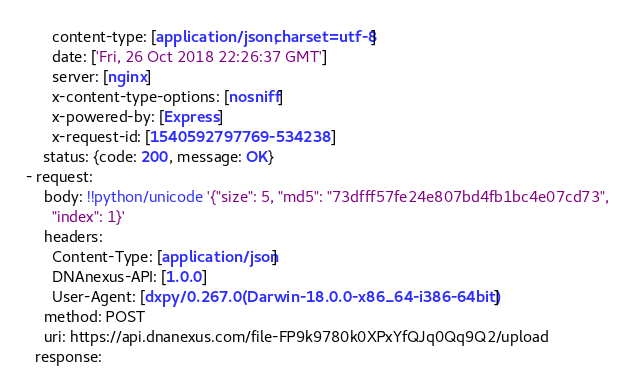<code> <loc_0><loc_0><loc_500><loc_500><_YAML_>      content-type: [application/json; charset=utf-8]
      date: ['Fri, 26 Oct 2018 22:26:37 GMT']
      server: [nginx]
      x-content-type-options: [nosniff]
      x-powered-by: [Express]
      x-request-id: [1540592797769-534238]
    status: {code: 200, message: OK}
- request:
    body: !!python/unicode '{"size": 5, "md5": "73dfff57fe24e807bd4fb1bc4e07cd73",
      "index": 1}'
    headers:
      Content-Type: [application/json]
      DNAnexus-API: [1.0.0]
      User-Agent: [dxpy/0.267.0 (Darwin-18.0.0-x86_64-i386-64bit)]
    method: POST
    uri: https://api.dnanexus.com/file-FP9k9780k0XPxYfQJq0Qq9Q2/upload
  response:</code> 